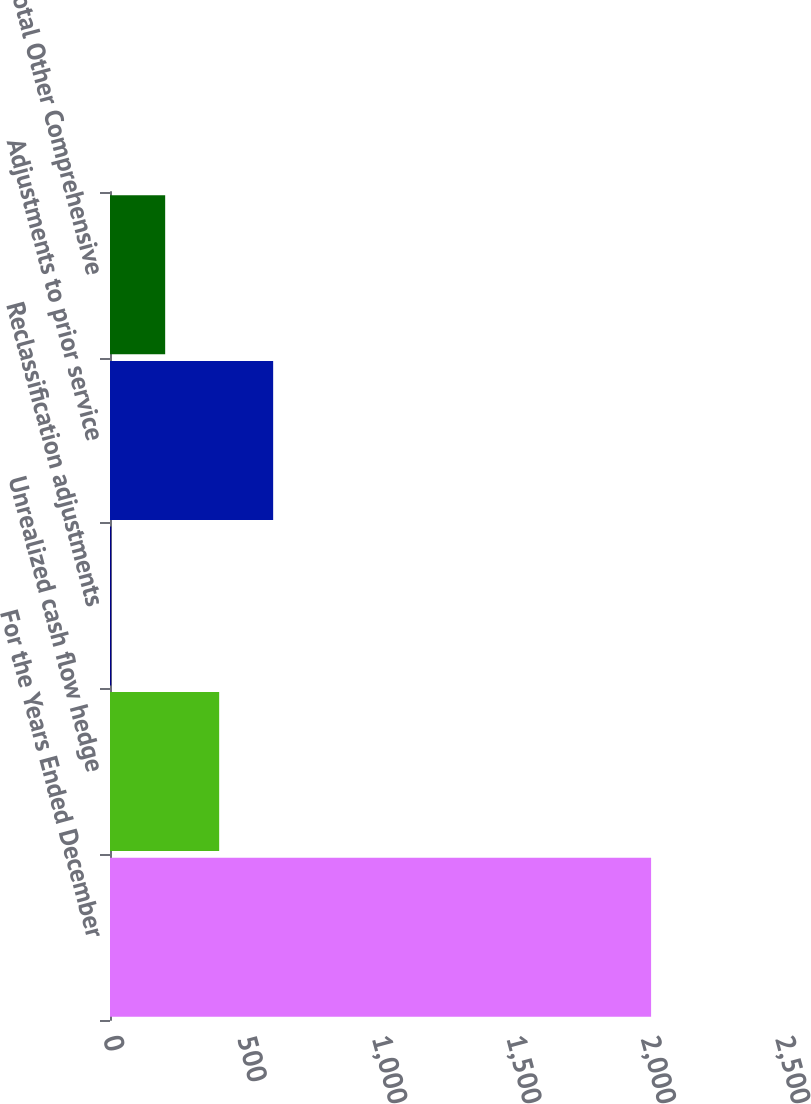Convert chart to OTSL. <chart><loc_0><loc_0><loc_500><loc_500><bar_chart><fcel>For the Years Ended December<fcel>Unrealized cash flow hedge<fcel>Reclassification adjustments<fcel>Adjustments to prior service<fcel>Total Other Comprehensive<nl><fcel>2013<fcel>406.12<fcel>4.4<fcel>606.98<fcel>205.26<nl></chart> 